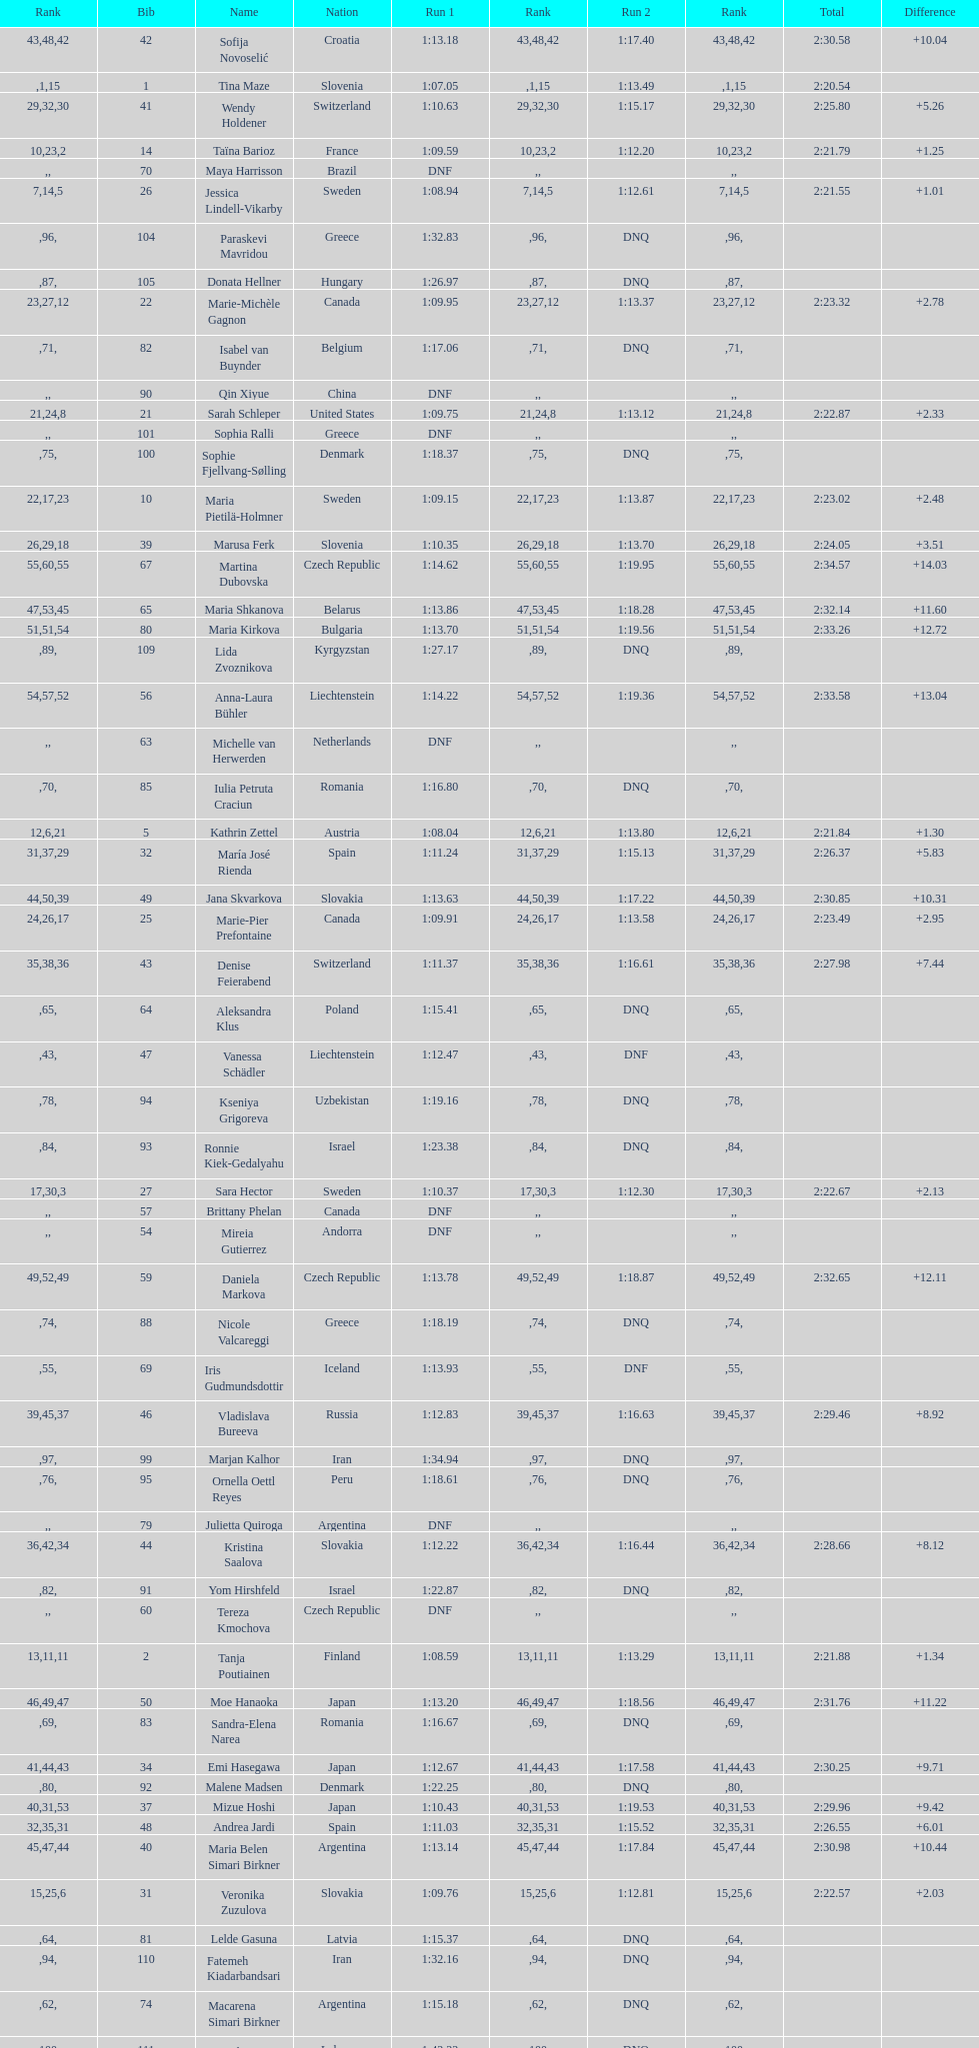Who was the last competitor to actually finish both runs? Martina Dubovska. 